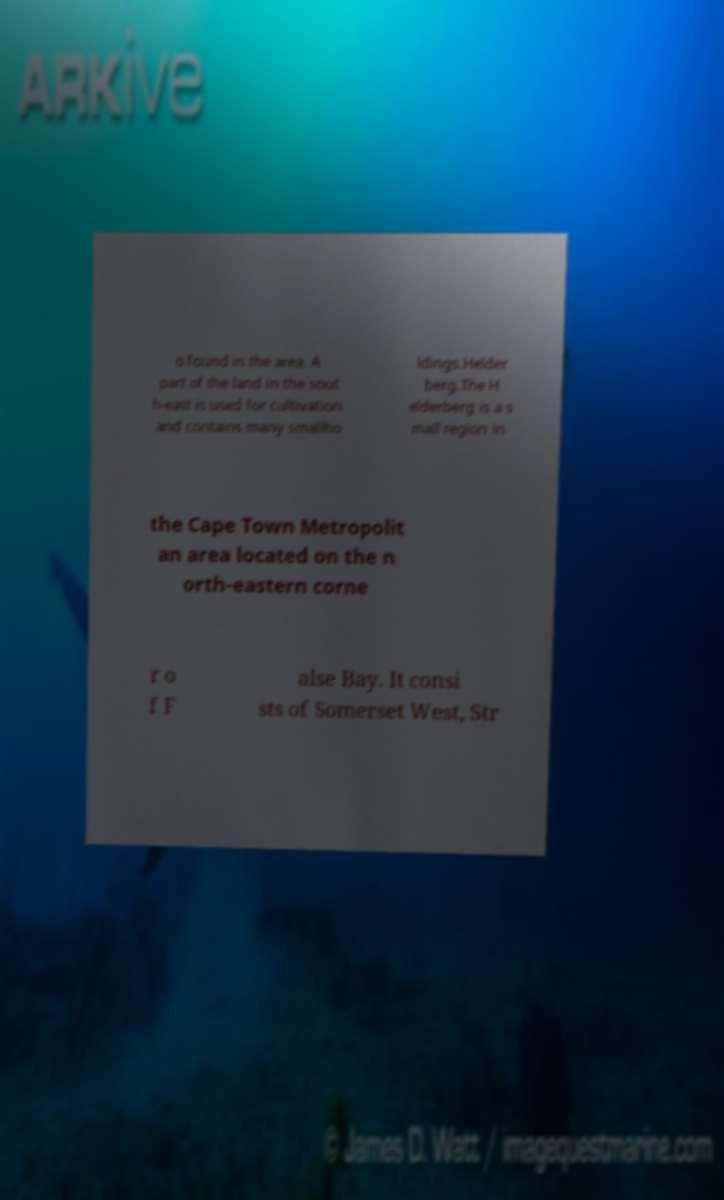Can you accurately transcribe the text from the provided image for me? o found in the area. A part of the land in the sout h-east is used for cultivation and contains many smallho ldings.Helder berg.The H elderberg is a s mall region in the Cape Town Metropolit an area located on the n orth-eastern corne r o f F alse Bay. It consi sts of Somerset West, Str 